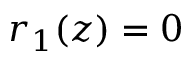<formula> <loc_0><loc_0><loc_500><loc_500>r _ { 1 } ( z ) = 0</formula> 